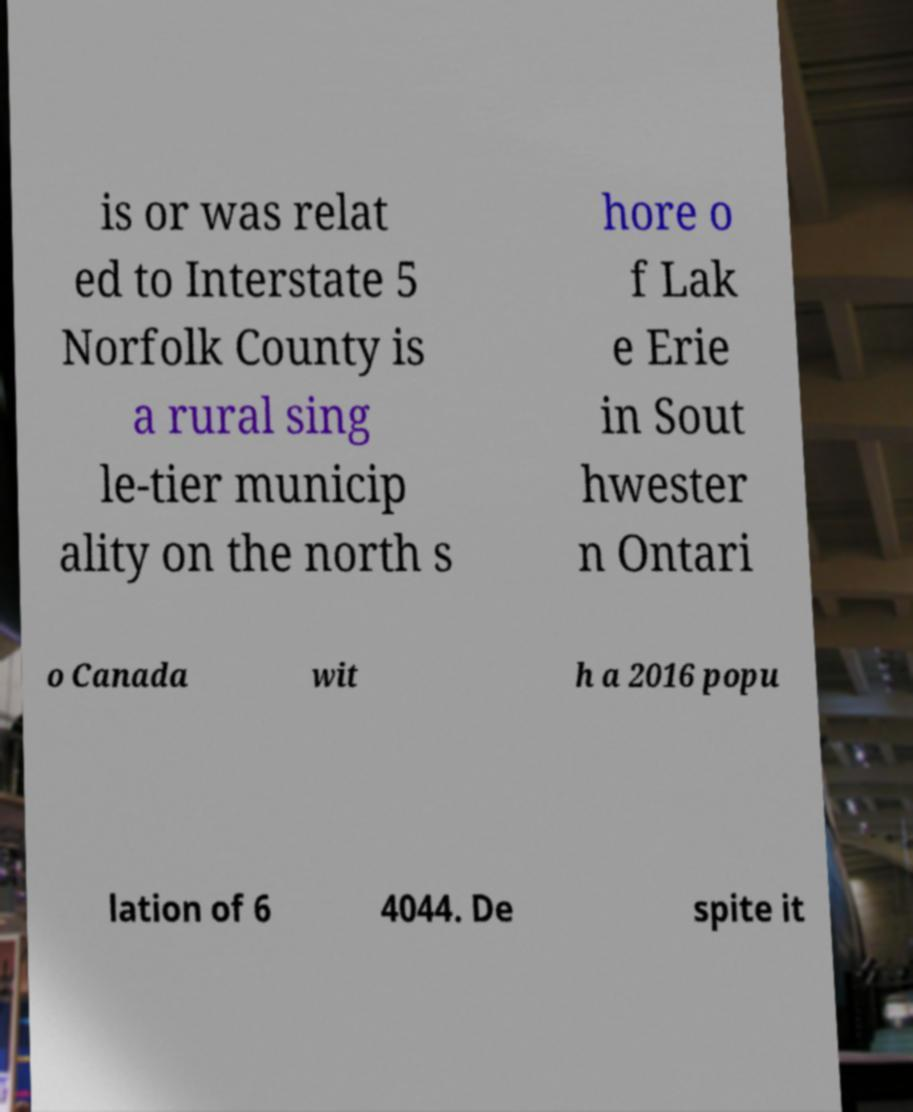What messages or text are displayed in this image? I need them in a readable, typed format. is or was relat ed to Interstate 5 Norfolk County is a rural sing le-tier municip ality on the north s hore o f Lak e Erie in Sout hwester n Ontari o Canada wit h a 2016 popu lation of 6 4044. De spite it 